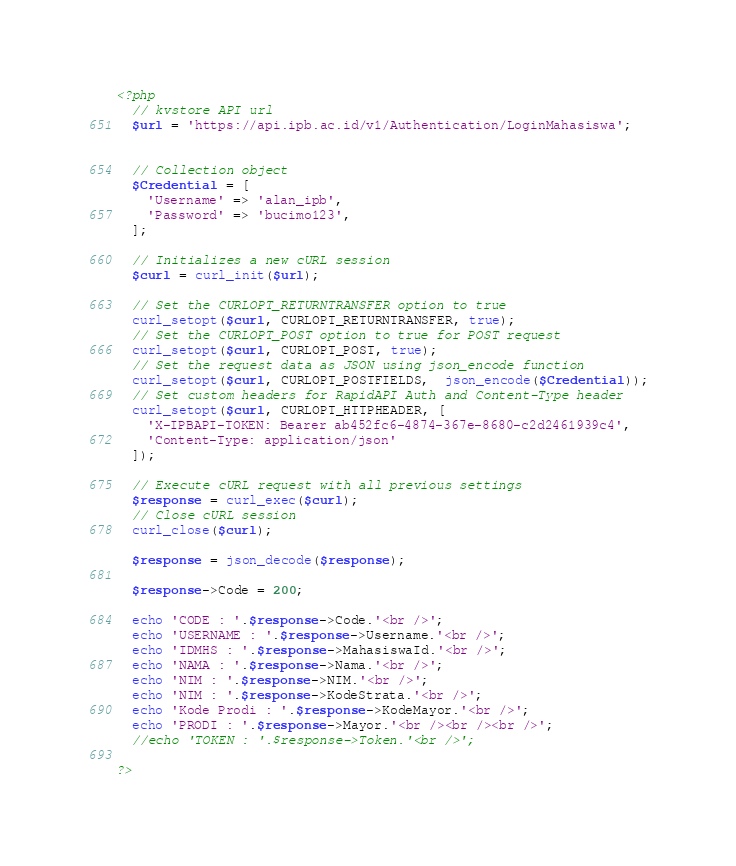<code> <loc_0><loc_0><loc_500><loc_500><_PHP_><?php
  // kvstore API url
  $url = 'https://api.ipb.ac.id/v1/Authentication/LoginMahasiswa';


  // Collection object
  $Credential = [
    'Username' => 'alan_ipb',
    'Password' => 'bucimo123',
  ];

  // Initializes a new cURL session
  $curl = curl_init($url);

  // Set the CURLOPT_RETURNTRANSFER option to true
  curl_setopt($curl, CURLOPT_RETURNTRANSFER, true);
  // Set the CURLOPT_POST option to true for POST request
  curl_setopt($curl, CURLOPT_POST, true);
  // Set the request data as JSON using json_encode function
  curl_setopt($curl, CURLOPT_POSTFIELDS,  json_encode($Credential));
  // Set custom headers for RapidAPI Auth and Content-Type header
  curl_setopt($curl, CURLOPT_HTTPHEADER, [
    'X-IPBAPI-TOKEN: Bearer ab452fc6-4874-367e-8680-c2d2461939c4',
    'Content-Type: application/json'
  ]);

  // Execute cURL request with all previous settings
  $response = curl_exec($curl);
  // Close cURL session
  curl_close($curl);

  $response = json_decode($response);

  $response->Code = 200;
  
  echo 'CODE : '.$response->Code.'<br />';
  echo 'USERNAME : '.$response->Username.'<br />';
  echo 'IDMHS : '.$response->MahasiswaId.'<br />';
  echo 'NAMA : '.$response->Nama.'<br />';
  echo 'NIM : '.$response->NIM.'<br />';
  echo 'NIM : '.$response->KodeStrata.'<br />';
  echo 'Kode Prodi : '.$response->KodeMayor.'<br />';
  echo 'PRODI : '.$response->Mayor.'<br /><br /><br />';
  //echo 'TOKEN : '.$response->Token.'<br />';

?></code> 